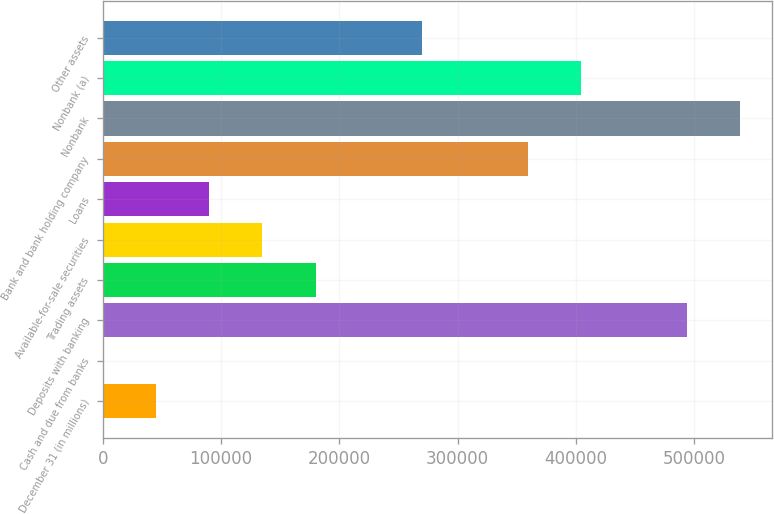Convert chart. <chart><loc_0><loc_0><loc_500><loc_500><bar_chart><fcel>December 31 (in millions)<fcel>Cash and due from banks<fcel>Deposits with banking<fcel>Trading assets<fcel>Available-for-sale securities<fcel>Loans<fcel>Bank and bank holding company<fcel>Nonbank<fcel>Nonbank (a)<fcel>Other assets<nl><fcel>45120.8<fcel>216<fcel>494169<fcel>179835<fcel>134930<fcel>90025.6<fcel>359454<fcel>539074<fcel>404359<fcel>269645<nl></chart> 